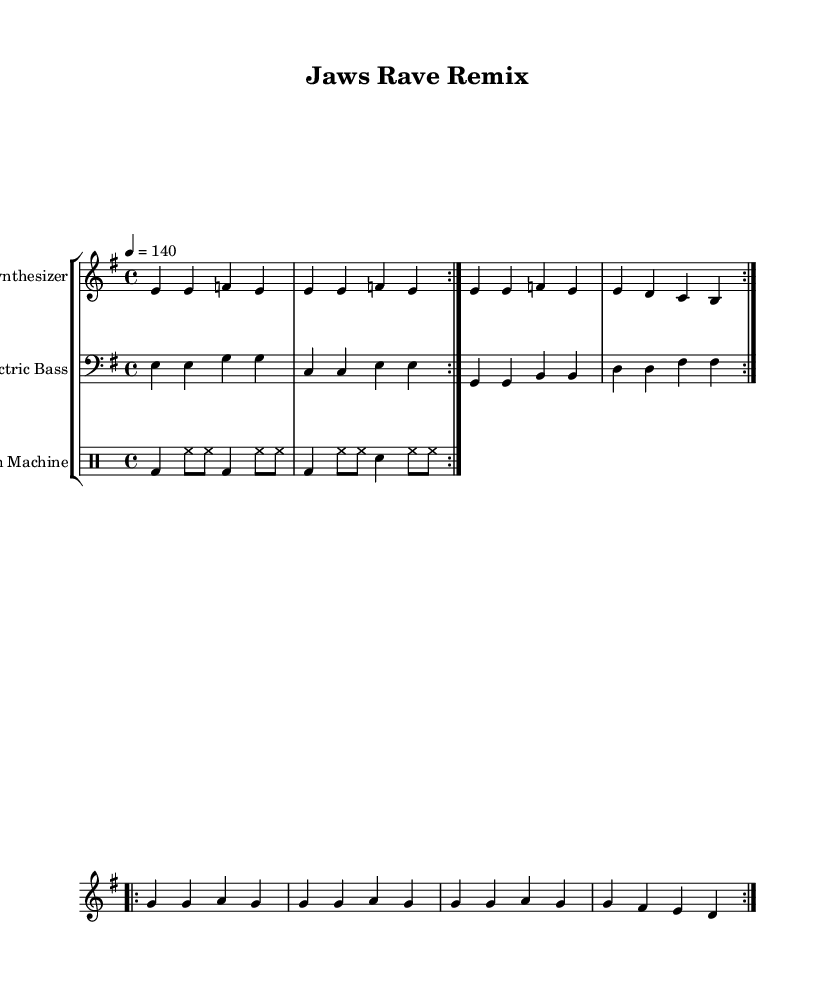What is the key signature of this music? The key signature shown is E minor, which has one sharp (F#). This is indicated at the beginning of the staff.
Answer: E minor What is the time signature of the piece? The time signature listed is 4/4, which means there are four beats in each measure and the quarter note gets one beat. This is visible at the beginning of the score.
Answer: 4/4 What is the tempo marking for this piece? The tempo marking indicates a speed of 140 beats per minute, which is expressed as "4 = 140". This is noted at the beginning of the first staff.
Answer: 140 How many times is the first section repeated? The first section is marked with "volta 2", indicating it should be played twice before moving on. This is observed in the repeat signs found in the music.
Answer: 2 What kind of instruments are used in this piece? The instruments listed in the music are "Synthesizer," "Electric Bass," and "Drum Machine." These are identified at the beginning of each staff.
Answer: Synthesizer, Electric Bass, Drum Machine How many beats does each measure contain? Each measure contains 4 beats, as indicated by the 4/4 time signature. This standard time signature confirms that each measure is counted in quarters.
Answer: 4 What is the rhythm pattern of the drum machine? The drum machine rhythm follows a pattern of bass drum and hi-hat for the first two beats and continues with bass drum and snare for the next two beats, as seen in the drum staff.
Answer: Bass and snare pattern 